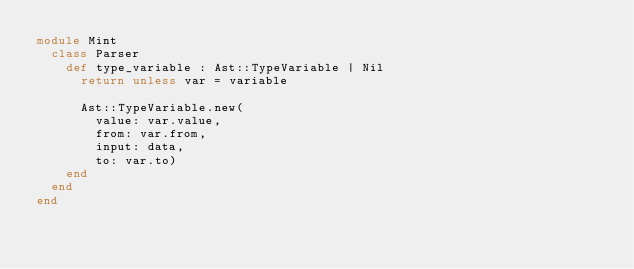Convert code to text. <code><loc_0><loc_0><loc_500><loc_500><_Crystal_>module Mint
  class Parser
    def type_variable : Ast::TypeVariable | Nil
      return unless var = variable

      Ast::TypeVariable.new(
        value: var.value,
        from: var.from,
        input: data,
        to: var.to)
    end
  end
end
</code> 